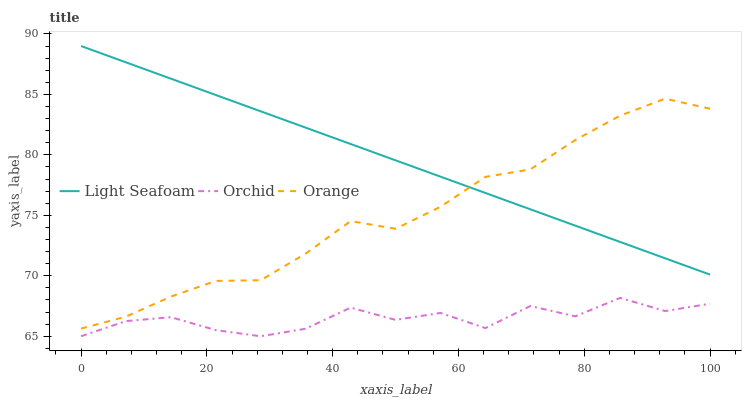Does Orchid have the minimum area under the curve?
Answer yes or no. Yes. Does Light Seafoam have the maximum area under the curve?
Answer yes or no. Yes. Does Light Seafoam have the minimum area under the curve?
Answer yes or no. No. Does Orchid have the maximum area under the curve?
Answer yes or no. No. Is Light Seafoam the smoothest?
Answer yes or no. Yes. Is Orchid the roughest?
Answer yes or no. Yes. Is Orchid the smoothest?
Answer yes or no. No. Is Light Seafoam the roughest?
Answer yes or no. No. Does Orchid have the lowest value?
Answer yes or no. Yes. Does Light Seafoam have the lowest value?
Answer yes or no. No. Does Light Seafoam have the highest value?
Answer yes or no. Yes. Does Orchid have the highest value?
Answer yes or no. No. Is Orchid less than Orange?
Answer yes or no. Yes. Is Orange greater than Orchid?
Answer yes or no. Yes. Does Orange intersect Light Seafoam?
Answer yes or no. Yes. Is Orange less than Light Seafoam?
Answer yes or no. No. Is Orange greater than Light Seafoam?
Answer yes or no. No. Does Orchid intersect Orange?
Answer yes or no. No. 